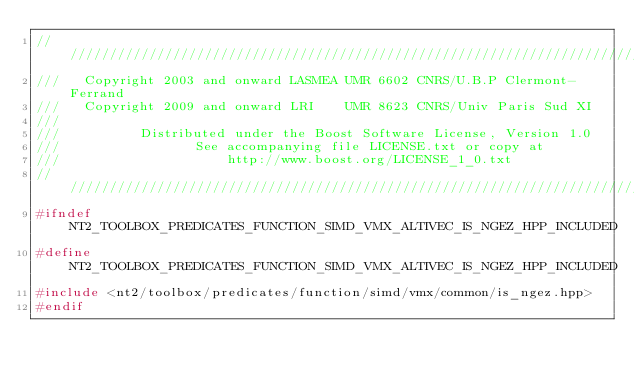<code> <loc_0><loc_0><loc_500><loc_500><_C++_>//////////////////////////////////////////////////////////////////////////////
///   Copyright 2003 and onward LASMEA UMR 6602 CNRS/U.B.P Clermont-Ferrand
///   Copyright 2009 and onward LRI    UMR 8623 CNRS/Univ Paris Sud XI
///
///          Distributed under the Boost Software License, Version 1.0
///                 See accompanying file LICENSE.txt or copy at
///                     http://www.boost.org/LICENSE_1_0.txt
//////////////////////////////////////////////////////////////////////////////
#ifndef NT2_TOOLBOX_PREDICATES_FUNCTION_SIMD_VMX_ALTIVEC_IS_NGEZ_HPP_INCLUDED
#define NT2_TOOLBOX_PREDICATES_FUNCTION_SIMD_VMX_ALTIVEC_IS_NGEZ_HPP_INCLUDED
#include <nt2/toolbox/predicates/function/simd/vmx/common/is_ngez.hpp>
#endif
</code> 